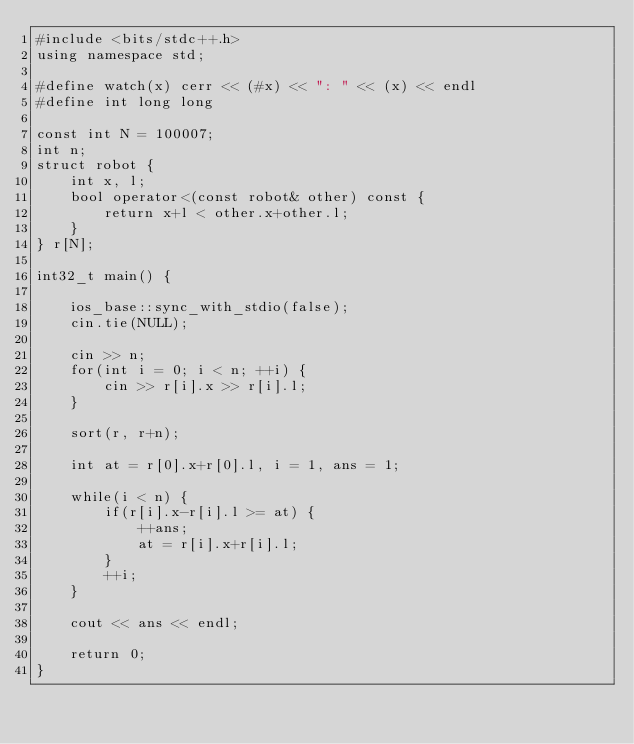Convert code to text. <code><loc_0><loc_0><loc_500><loc_500><_C++_>#include <bits/stdc++.h>
using namespace std;

#define watch(x) cerr << (#x) << ": " << (x) << endl
#define int long long

const int N = 100007;
int n;
struct robot {
    int x, l;
    bool operator<(const robot& other) const {
        return x+l < other.x+other.l;
    }
} r[N];

int32_t main() {

    ios_base::sync_with_stdio(false);
    cin.tie(NULL);

    cin >> n;
    for(int i = 0; i < n; ++i) {
        cin >> r[i].x >> r[i].l;
    }

    sort(r, r+n);

    int at = r[0].x+r[0].l, i = 1, ans = 1;

    while(i < n) {
        if(r[i].x-r[i].l >= at) {
            ++ans;
            at = r[i].x+r[i].l;
        }
        ++i;
    }

    cout << ans << endl;
    
    return 0;
}
</code> 